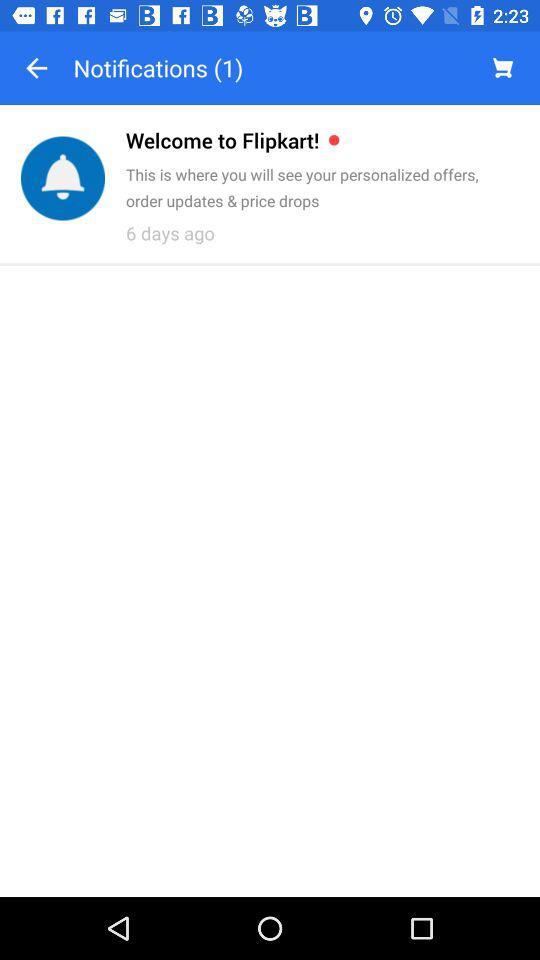How many items are in the cart?
When the provided information is insufficient, respond with <no answer>. <no answer> 